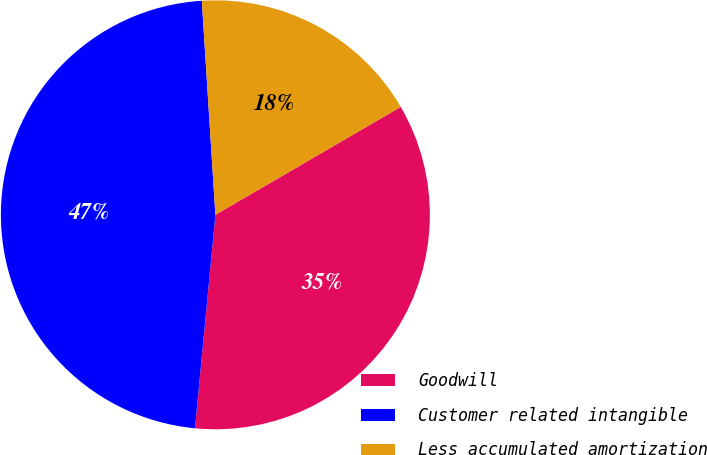Convert chart to OTSL. <chart><loc_0><loc_0><loc_500><loc_500><pie_chart><fcel>Goodwill<fcel>Customer related intangible<fcel>Less accumulated amortization<nl><fcel>34.91%<fcel>47.48%<fcel>17.62%<nl></chart> 